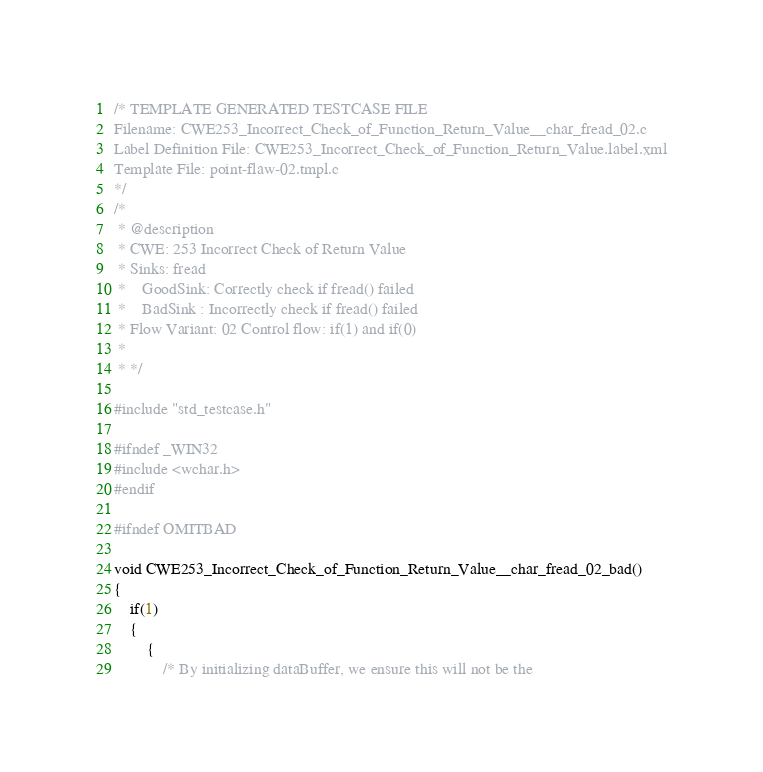<code> <loc_0><loc_0><loc_500><loc_500><_C_>/* TEMPLATE GENERATED TESTCASE FILE
Filename: CWE253_Incorrect_Check_of_Function_Return_Value__char_fread_02.c
Label Definition File: CWE253_Incorrect_Check_of_Function_Return_Value.label.xml
Template File: point-flaw-02.tmpl.c
*/
/*
 * @description
 * CWE: 253 Incorrect Check of Return Value
 * Sinks: fread
 *    GoodSink: Correctly check if fread() failed
 *    BadSink : Incorrectly check if fread() failed
 * Flow Variant: 02 Control flow: if(1) and if(0)
 *
 * */

#include "std_testcase.h"

#ifndef _WIN32
#include <wchar.h>
#endif

#ifndef OMITBAD

void CWE253_Incorrect_Check_of_Function_Return_Value__char_fread_02_bad()
{
    if(1)
    {
        {
            /* By initializing dataBuffer, we ensure this will not be the</code> 